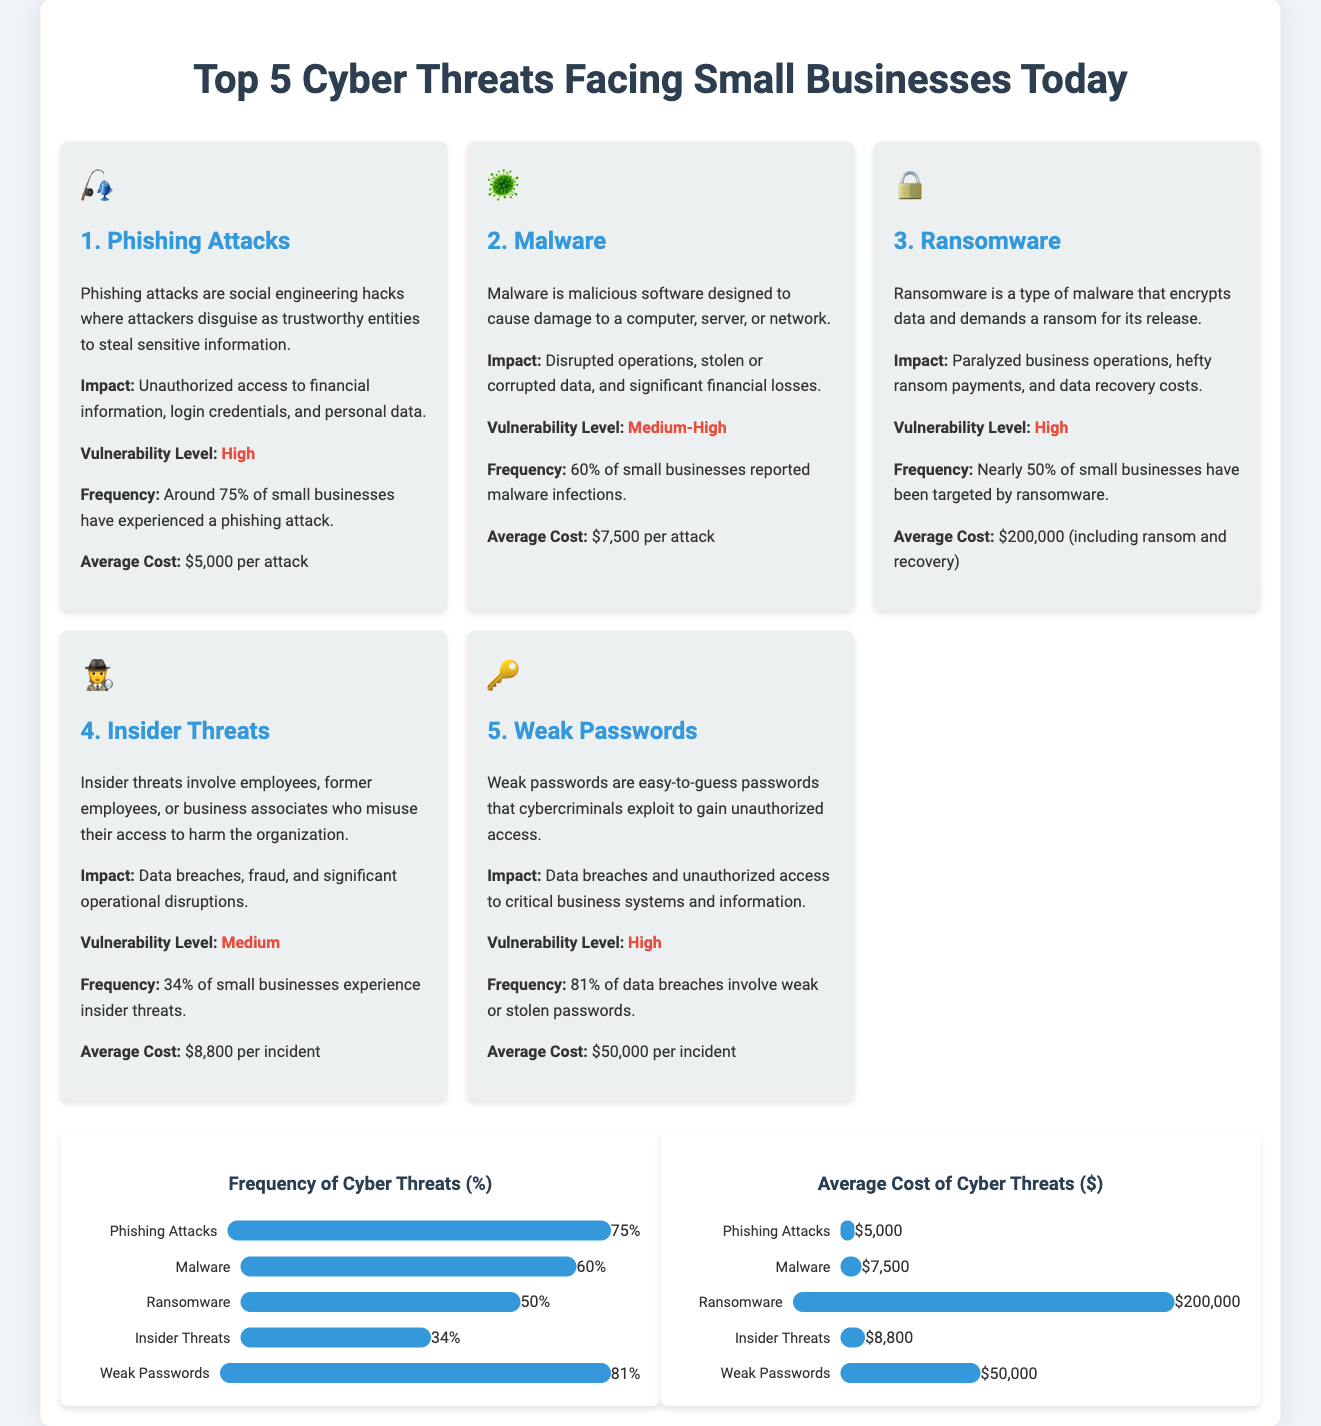What are the top two cyber threats? The document lists phishing attacks and malware as the top two cyber threats facing small businesses.
Answer: Phishing attacks, Malware What is the frequency of ransomware attacks? The document states that nearly 50% of small businesses have been targeted by ransomware.
Answer: 50% What is the average cost of a ransomware attack? The infographic provides the average cost of a ransomware attack, which includes ransom and recovery expenses.
Answer: $200,000 Which cyber threat has the highest vulnerability level? The document indicates that phishing attacks and ransomware have the highest vulnerability level.
Answer: Phishing attacks, Ransomware What percentage of data breaches involve weak passwords? The document specifies that 81% of data breaches involve weak or stolen passwords.
Answer: 81% How many small businesses report malware infections? The infographic states that 60% of small businesses reported malware infections.
Answer: 60% What impact do insider threats have on businesses? The document describes the impact of insider threats as data breaches, fraud, and significant operational disruptions.
Answer: Data breaches, fraud, operational disruptions What is the vulnerability level of malware? The document indicates that malware has a medium-high vulnerability level.
Answer: Medium-High 